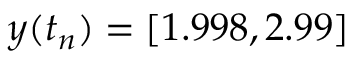Convert formula to latex. <formula><loc_0><loc_0><loc_500><loc_500>y ( t _ { n } ) = [ 1 . 9 9 8 , 2 . 9 9 ]</formula> 